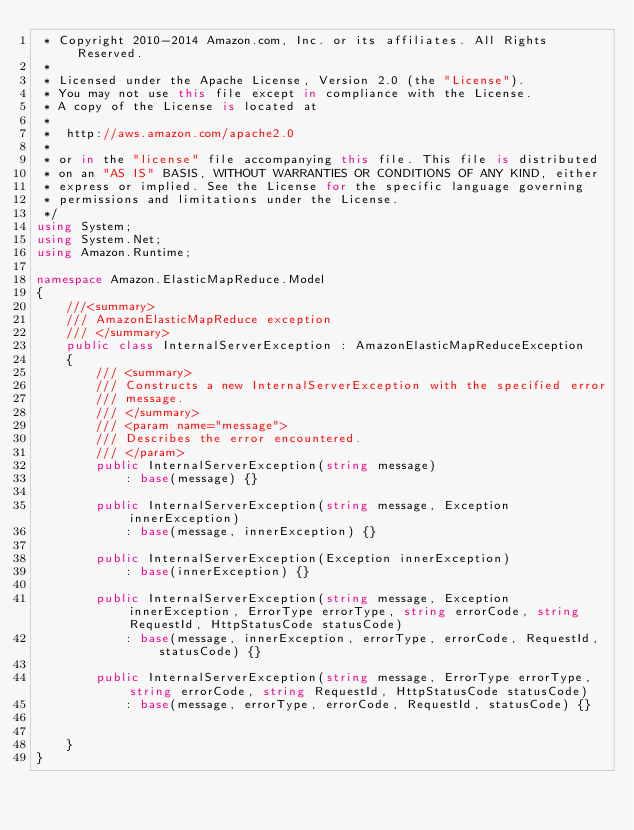<code> <loc_0><loc_0><loc_500><loc_500><_C#_> * Copyright 2010-2014 Amazon.com, Inc. or its affiliates. All Rights Reserved.
 * 
 * Licensed under the Apache License, Version 2.0 (the "License").
 * You may not use this file except in compliance with the License.
 * A copy of the License is located at
 * 
 *  http://aws.amazon.com/apache2.0
 * 
 * or in the "license" file accompanying this file. This file is distributed
 * on an "AS IS" BASIS, WITHOUT WARRANTIES OR CONDITIONS OF ANY KIND, either
 * express or implied. See the License for the specific language governing
 * permissions and limitations under the License.
 */
using System;
using System.Net;
using Amazon.Runtime;

namespace Amazon.ElasticMapReduce.Model
{
    ///<summary>
    /// AmazonElasticMapReduce exception
    /// </summary>
    public class InternalServerException : AmazonElasticMapReduceException 
    {
        /// <summary>
        /// Constructs a new InternalServerException with the specified error
        /// message.
        /// </summary>
        /// <param name="message">
        /// Describes the error encountered.
        /// </param>
        public InternalServerException(string message) 
            : base(message) {}
          
        public InternalServerException(string message, Exception innerException) 
            : base(message, innerException) {}
            
        public InternalServerException(Exception innerException) 
            : base(innerException) {}
            
        public InternalServerException(string message, Exception innerException, ErrorType errorType, string errorCode, string RequestId, HttpStatusCode statusCode) 
            : base(message, innerException, errorType, errorCode, RequestId, statusCode) {}

        public InternalServerException(string message, ErrorType errorType, string errorCode, string RequestId, HttpStatusCode statusCode) 
            : base(message, errorType, errorCode, RequestId, statusCode) {}

        
    }
}
</code> 